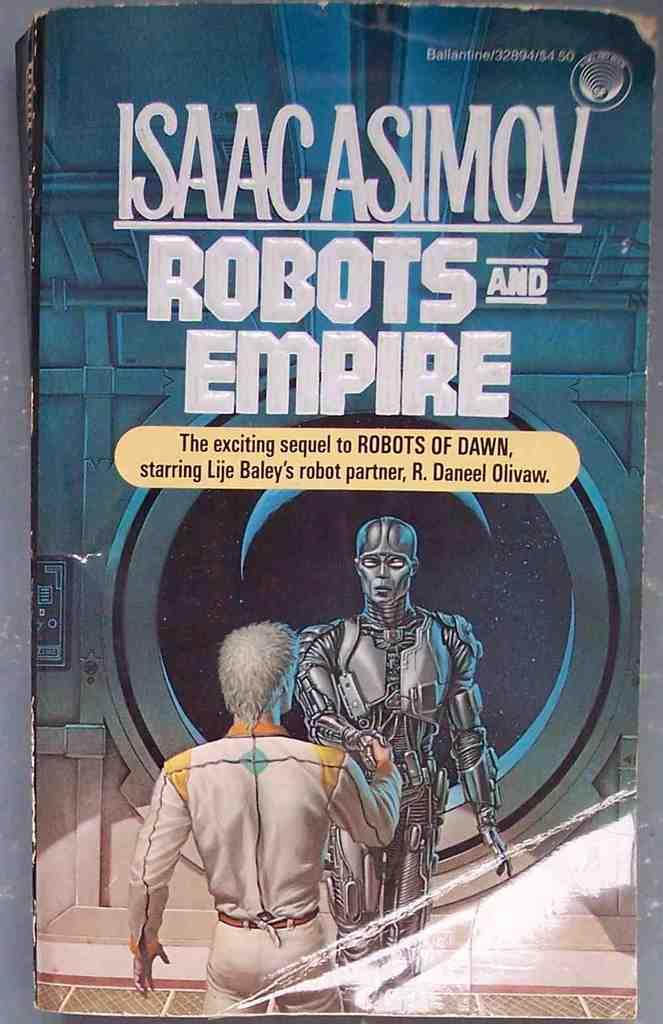<image>
Give a short and clear explanation of the subsequent image. A science fiction book titled Robots and Empire has a blue cover. 